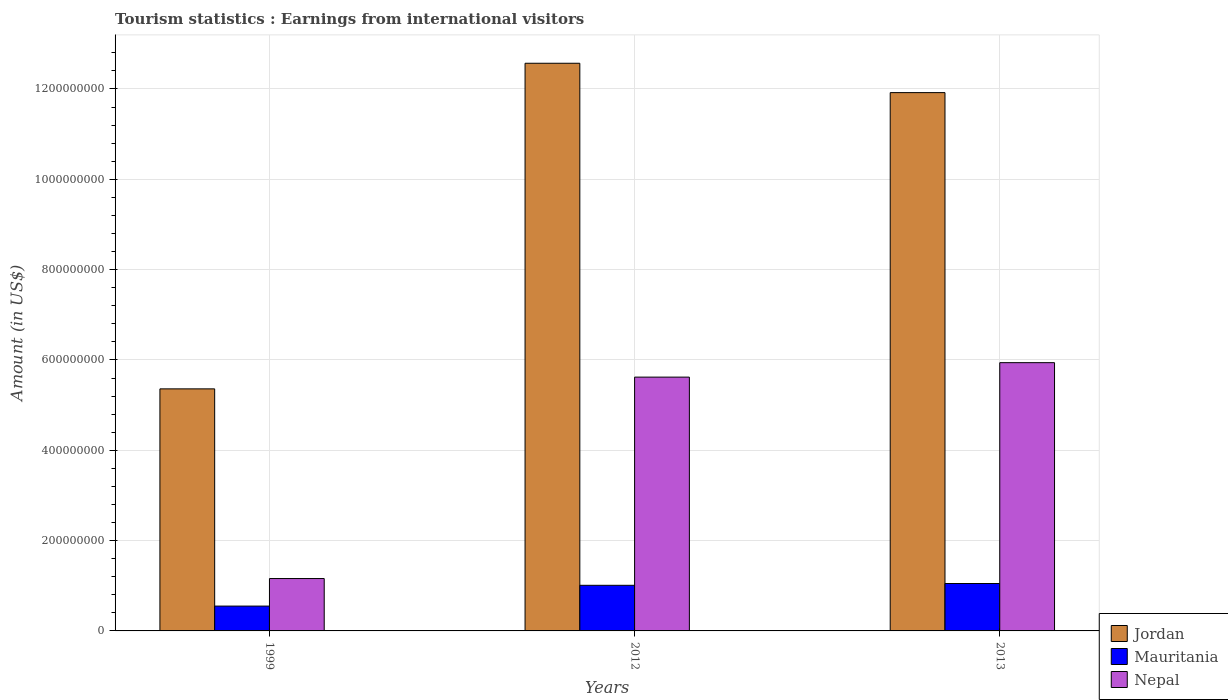How many different coloured bars are there?
Your answer should be very brief. 3. Are the number of bars on each tick of the X-axis equal?
Make the answer very short. Yes. How many bars are there on the 2nd tick from the left?
Provide a succinct answer. 3. How many bars are there on the 3rd tick from the right?
Provide a succinct answer. 3. What is the label of the 2nd group of bars from the left?
Provide a short and direct response. 2012. What is the earnings from international visitors in Mauritania in 2012?
Your response must be concise. 1.01e+08. Across all years, what is the maximum earnings from international visitors in Mauritania?
Keep it short and to the point. 1.05e+08. Across all years, what is the minimum earnings from international visitors in Jordan?
Give a very brief answer. 5.36e+08. What is the total earnings from international visitors in Jordan in the graph?
Your answer should be compact. 2.98e+09. What is the difference between the earnings from international visitors in Mauritania in 1999 and that in 2012?
Ensure brevity in your answer.  -4.60e+07. What is the difference between the earnings from international visitors in Jordan in 2013 and the earnings from international visitors in Nepal in 1999?
Ensure brevity in your answer.  1.08e+09. What is the average earnings from international visitors in Mauritania per year?
Make the answer very short. 8.70e+07. In the year 2013, what is the difference between the earnings from international visitors in Jordan and earnings from international visitors in Nepal?
Provide a succinct answer. 5.98e+08. In how many years, is the earnings from international visitors in Jordan greater than 680000000 US$?
Make the answer very short. 2. What is the ratio of the earnings from international visitors in Mauritania in 1999 to that in 2013?
Your answer should be compact. 0.52. Is the earnings from international visitors in Nepal in 1999 less than that in 2013?
Ensure brevity in your answer.  Yes. Is the difference between the earnings from international visitors in Jordan in 2012 and 2013 greater than the difference between the earnings from international visitors in Nepal in 2012 and 2013?
Your answer should be compact. Yes. What is the difference between the highest and the second highest earnings from international visitors in Nepal?
Provide a succinct answer. 3.20e+07. What is the difference between the highest and the lowest earnings from international visitors in Nepal?
Your response must be concise. 4.78e+08. What does the 1st bar from the left in 2012 represents?
Provide a short and direct response. Jordan. What does the 2nd bar from the right in 1999 represents?
Offer a terse response. Mauritania. How many bars are there?
Your answer should be very brief. 9. Are all the bars in the graph horizontal?
Offer a terse response. No. How many years are there in the graph?
Your response must be concise. 3. Does the graph contain grids?
Provide a short and direct response. Yes. Where does the legend appear in the graph?
Ensure brevity in your answer.  Bottom right. How many legend labels are there?
Your answer should be very brief. 3. What is the title of the graph?
Your answer should be very brief. Tourism statistics : Earnings from international visitors. What is the label or title of the Y-axis?
Your answer should be compact. Amount (in US$). What is the Amount (in US$) of Jordan in 1999?
Ensure brevity in your answer.  5.36e+08. What is the Amount (in US$) of Mauritania in 1999?
Make the answer very short. 5.50e+07. What is the Amount (in US$) of Nepal in 1999?
Your response must be concise. 1.16e+08. What is the Amount (in US$) in Jordan in 2012?
Provide a short and direct response. 1.26e+09. What is the Amount (in US$) in Mauritania in 2012?
Your answer should be compact. 1.01e+08. What is the Amount (in US$) in Nepal in 2012?
Your answer should be compact. 5.62e+08. What is the Amount (in US$) of Jordan in 2013?
Provide a succinct answer. 1.19e+09. What is the Amount (in US$) of Mauritania in 2013?
Make the answer very short. 1.05e+08. What is the Amount (in US$) in Nepal in 2013?
Provide a short and direct response. 5.94e+08. Across all years, what is the maximum Amount (in US$) of Jordan?
Ensure brevity in your answer.  1.26e+09. Across all years, what is the maximum Amount (in US$) of Mauritania?
Your answer should be compact. 1.05e+08. Across all years, what is the maximum Amount (in US$) in Nepal?
Ensure brevity in your answer.  5.94e+08. Across all years, what is the minimum Amount (in US$) in Jordan?
Your answer should be very brief. 5.36e+08. Across all years, what is the minimum Amount (in US$) in Mauritania?
Offer a terse response. 5.50e+07. Across all years, what is the minimum Amount (in US$) of Nepal?
Provide a succinct answer. 1.16e+08. What is the total Amount (in US$) in Jordan in the graph?
Your response must be concise. 2.98e+09. What is the total Amount (in US$) of Mauritania in the graph?
Ensure brevity in your answer.  2.61e+08. What is the total Amount (in US$) in Nepal in the graph?
Ensure brevity in your answer.  1.27e+09. What is the difference between the Amount (in US$) of Jordan in 1999 and that in 2012?
Give a very brief answer. -7.21e+08. What is the difference between the Amount (in US$) of Mauritania in 1999 and that in 2012?
Provide a succinct answer. -4.60e+07. What is the difference between the Amount (in US$) in Nepal in 1999 and that in 2012?
Offer a very short reply. -4.46e+08. What is the difference between the Amount (in US$) in Jordan in 1999 and that in 2013?
Make the answer very short. -6.56e+08. What is the difference between the Amount (in US$) of Mauritania in 1999 and that in 2013?
Provide a succinct answer. -5.00e+07. What is the difference between the Amount (in US$) in Nepal in 1999 and that in 2013?
Your answer should be very brief. -4.78e+08. What is the difference between the Amount (in US$) in Jordan in 2012 and that in 2013?
Give a very brief answer. 6.50e+07. What is the difference between the Amount (in US$) in Mauritania in 2012 and that in 2013?
Your answer should be very brief. -4.00e+06. What is the difference between the Amount (in US$) of Nepal in 2012 and that in 2013?
Offer a very short reply. -3.20e+07. What is the difference between the Amount (in US$) in Jordan in 1999 and the Amount (in US$) in Mauritania in 2012?
Provide a succinct answer. 4.35e+08. What is the difference between the Amount (in US$) of Jordan in 1999 and the Amount (in US$) of Nepal in 2012?
Ensure brevity in your answer.  -2.60e+07. What is the difference between the Amount (in US$) of Mauritania in 1999 and the Amount (in US$) of Nepal in 2012?
Ensure brevity in your answer.  -5.07e+08. What is the difference between the Amount (in US$) in Jordan in 1999 and the Amount (in US$) in Mauritania in 2013?
Ensure brevity in your answer.  4.31e+08. What is the difference between the Amount (in US$) of Jordan in 1999 and the Amount (in US$) of Nepal in 2013?
Provide a succinct answer. -5.80e+07. What is the difference between the Amount (in US$) of Mauritania in 1999 and the Amount (in US$) of Nepal in 2013?
Offer a terse response. -5.39e+08. What is the difference between the Amount (in US$) of Jordan in 2012 and the Amount (in US$) of Mauritania in 2013?
Your response must be concise. 1.15e+09. What is the difference between the Amount (in US$) in Jordan in 2012 and the Amount (in US$) in Nepal in 2013?
Provide a succinct answer. 6.63e+08. What is the difference between the Amount (in US$) of Mauritania in 2012 and the Amount (in US$) of Nepal in 2013?
Make the answer very short. -4.93e+08. What is the average Amount (in US$) of Jordan per year?
Offer a very short reply. 9.95e+08. What is the average Amount (in US$) in Mauritania per year?
Offer a terse response. 8.70e+07. What is the average Amount (in US$) in Nepal per year?
Keep it short and to the point. 4.24e+08. In the year 1999, what is the difference between the Amount (in US$) in Jordan and Amount (in US$) in Mauritania?
Your answer should be compact. 4.81e+08. In the year 1999, what is the difference between the Amount (in US$) of Jordan and Amount (in US$) of Nepal?
Provide a succinct answer. 4.20e+08. In the year 1999, what is the difference between the Amount (in US$) in Mauritania and Amount (in US$) in Nepal?
Make the answer very short. -6.10e+07. In the year 2012, what is the difference between the Amount (in US$) in Jordan and Amount (in US$) in Mauritania?
Give a very brief answer. 1.16e+09. In the year 2012, what is the difference between the Amount (in US$) in Jordan and Amount (in US$) in Nepal?
Ensure brevity in your answer.  6.95e+08. In the year 2012, what is the difference between the Amount (in US$) in Mauritania and Amount (in US$) in Nepal?
Your response must be concise. -4.61e+08. In the year 2013, what is the difference between the Amount (in US$) of Jordan and Amount (in US$) of Mauritania?
Give a very brief answer. 1.09e+09. In the year 2013, what is the difference between the Amount (in US$) of Jordan and Amount (in US$) of Nepal?
Your answer should be compact. 5.98e+08. In the year 2013, what is the difference between the Amount (in US$) in Mauritania and Amount (in US$) in Nepal?
Give a very brief answer. -4.89e+08. What is the ratio of the Amount (in US$) of Jordan in 1999 to that in 2012?
Offer a very short reply. 0.43. What is the ratio of the Amount (in US$) in Mauritania in 1999 to that in 2012?
Give a very brief answer. 0.54. What is the ratio of the Amount (in US$) of Nepal in 1999 to that in 2012?
Ensure brevity in your answer.  0.21. What is the ratio of the Amount (in US$) of Jordan in 1999 to that in 2013?
Give a very brief answer. 0.45. What is the ratio of the Amount (in US$) of Mauritania in 1999 to that in 2013?
Make the answer very short. 0.52. What is the ratio of the Amount (in US$) in Nepal in 1999 to that in 2013?
Offer a terse response. 0.2. What is the ratio of the Amount (in US$) in Jordan in 2012 to that in 2013?
Keep it short and to the point. 1.05. What is the ratio of the Amount (in US$) in Mauritania in 2012 to that in 2013?
Provide a short and direct response. 0.96. What is the ratio of the Amount (in US$) in Nepal in 2012 to that in 2013?
Offer a terse response. 0.95. What is the difference between the highest and the second highest Amount (in US$) in Jordan?
Offer a very short reply. 6.50e+07. What is the difference between the highest and the second highest Amount (in US$) of Mauritania?
Provide a short and direct response. 4.00e+06. What is the difference between the highest and the second highest Amount (in US$) of Nepal?
Keep it short and to the point. 3.20e+07. What is the difference between the highest and the lowest Amount (in US$) in Jordan?
Provide a short and direct response. 7.21e+08. What is the difference between the highest and the lowest Amount (in US$) of Nepal?
Make the answer very short. 4.78e+08. 